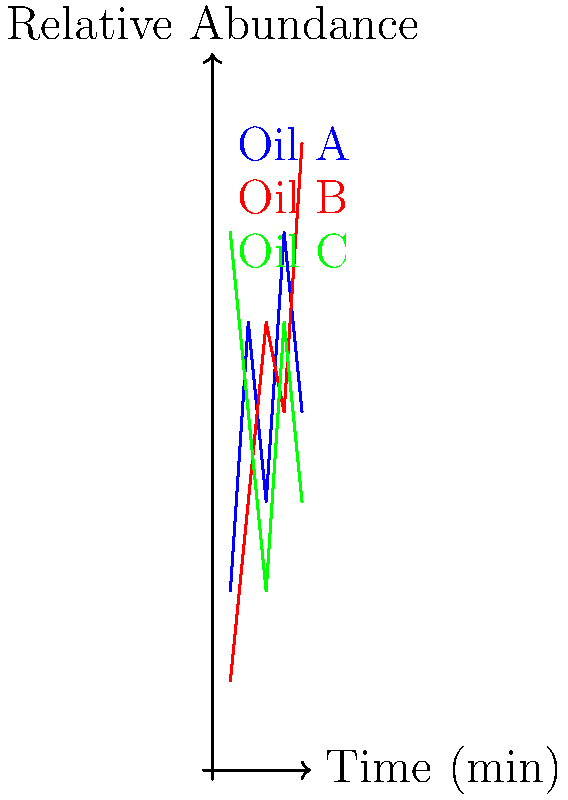Based on the GC-MS profiles shown in the graph, which essential oil is likely to have the highest concentration of monoterpenes, typically eluting earlier in the chromatogram? To answer this question, we need to analyze the GC-MS profiles of the three essential oils (A, B, and C) shown in the graph. Here's a step-by-step explanation:

1. Monoterpenes are typically lower molecular weight compounds that elute earlier in a GC-MS chromatogram.

2. The x-axis represents the retention time, with earlier eluting compounds appearing on the left side of the graph.

3. The y-axis represents the relative abundance of compounds at each time point.

4. Examining the profiles:
   - Oil A (blue line) shows high abundance early in the chromatogram, with peaks at 1 and 2 minutes.
   - Oil B (red line) shows lower abundance early on, with its highest peak at 5 minutes.
   - Oil C (green line) shows the highest abundance at 1 minute, followed by a decrease.

5. The high abundance of Oil C at the earliest time point (1 minute) suggests it has the highest concentration of early-eluting compounds.

6. Given that monoterpenes typically elute earlier, Oil C is most likely to have the highest concentration of monoterpenes.
Answer: Oil C 